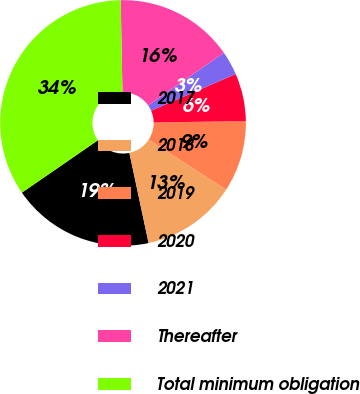<chart> <loc_0><loc_0><loc_500><loc_500><pie_chart><fcel>2017<fcel>2018<fcel>2019<fcel>2020<fcel>2021<fcel>Thereafter<fcel>Total minimum obligation<nl><fcel>18.73%<fcel>12.51%<fcel>9.39%<fcel>6.28%<fcel>3.16%<fcel>15.62%<fcel>34.3%<nl></chart> 